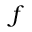<formula> <loc_0><loc_0><loc_500><loc_500>f</formula> 